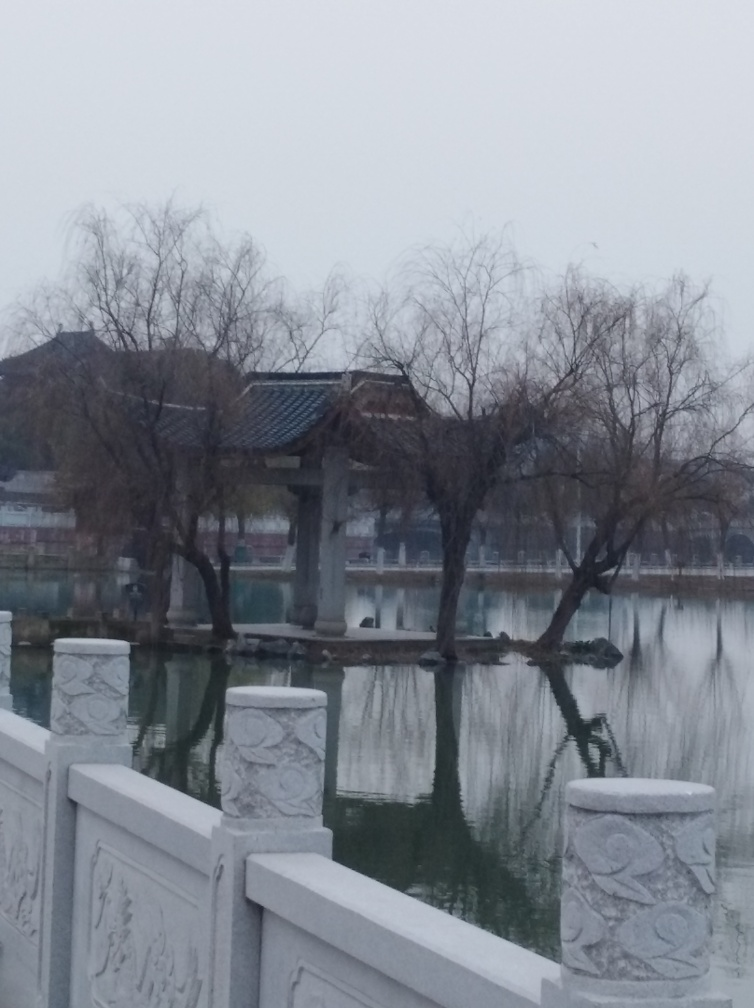Is the scene well-exposed? While the answer was simply 'A,' indicating that the scene is not well-exposed, it can be seen that the image has a relatively even distribution of light without harsh shadows or overly bright areas. However, the overall lighting seems a bit dull, which might give the impression of underexposure. An enhanced answer would therefore be: 'The scene appears to be evenly lit without harsh shadows or bright spots, suggesting a properly exposed scene. Despite this, the lighting lacks vibrancy, making the scene appear less lively and potentially leading to the perception of underexposure.' 